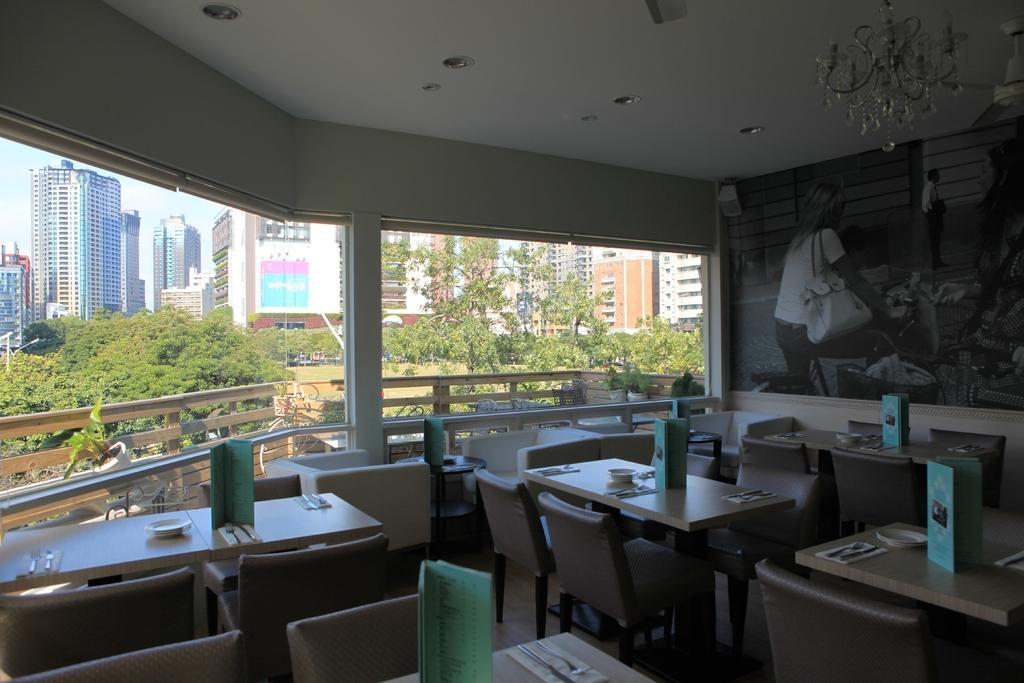Could you give a brief overview of what you see in this image? In this image I can see few buildings, trees, fencing, few lights, chairs, few tables and the sky. I can see few spoons, plates and few objects on the tables. 